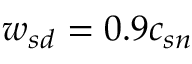Convert formula to latex. <formula><loc_0><loc_0><loc_500><loc_500>{ w _ { s d } } = 0 . 9 c _ { s n }</formula> 